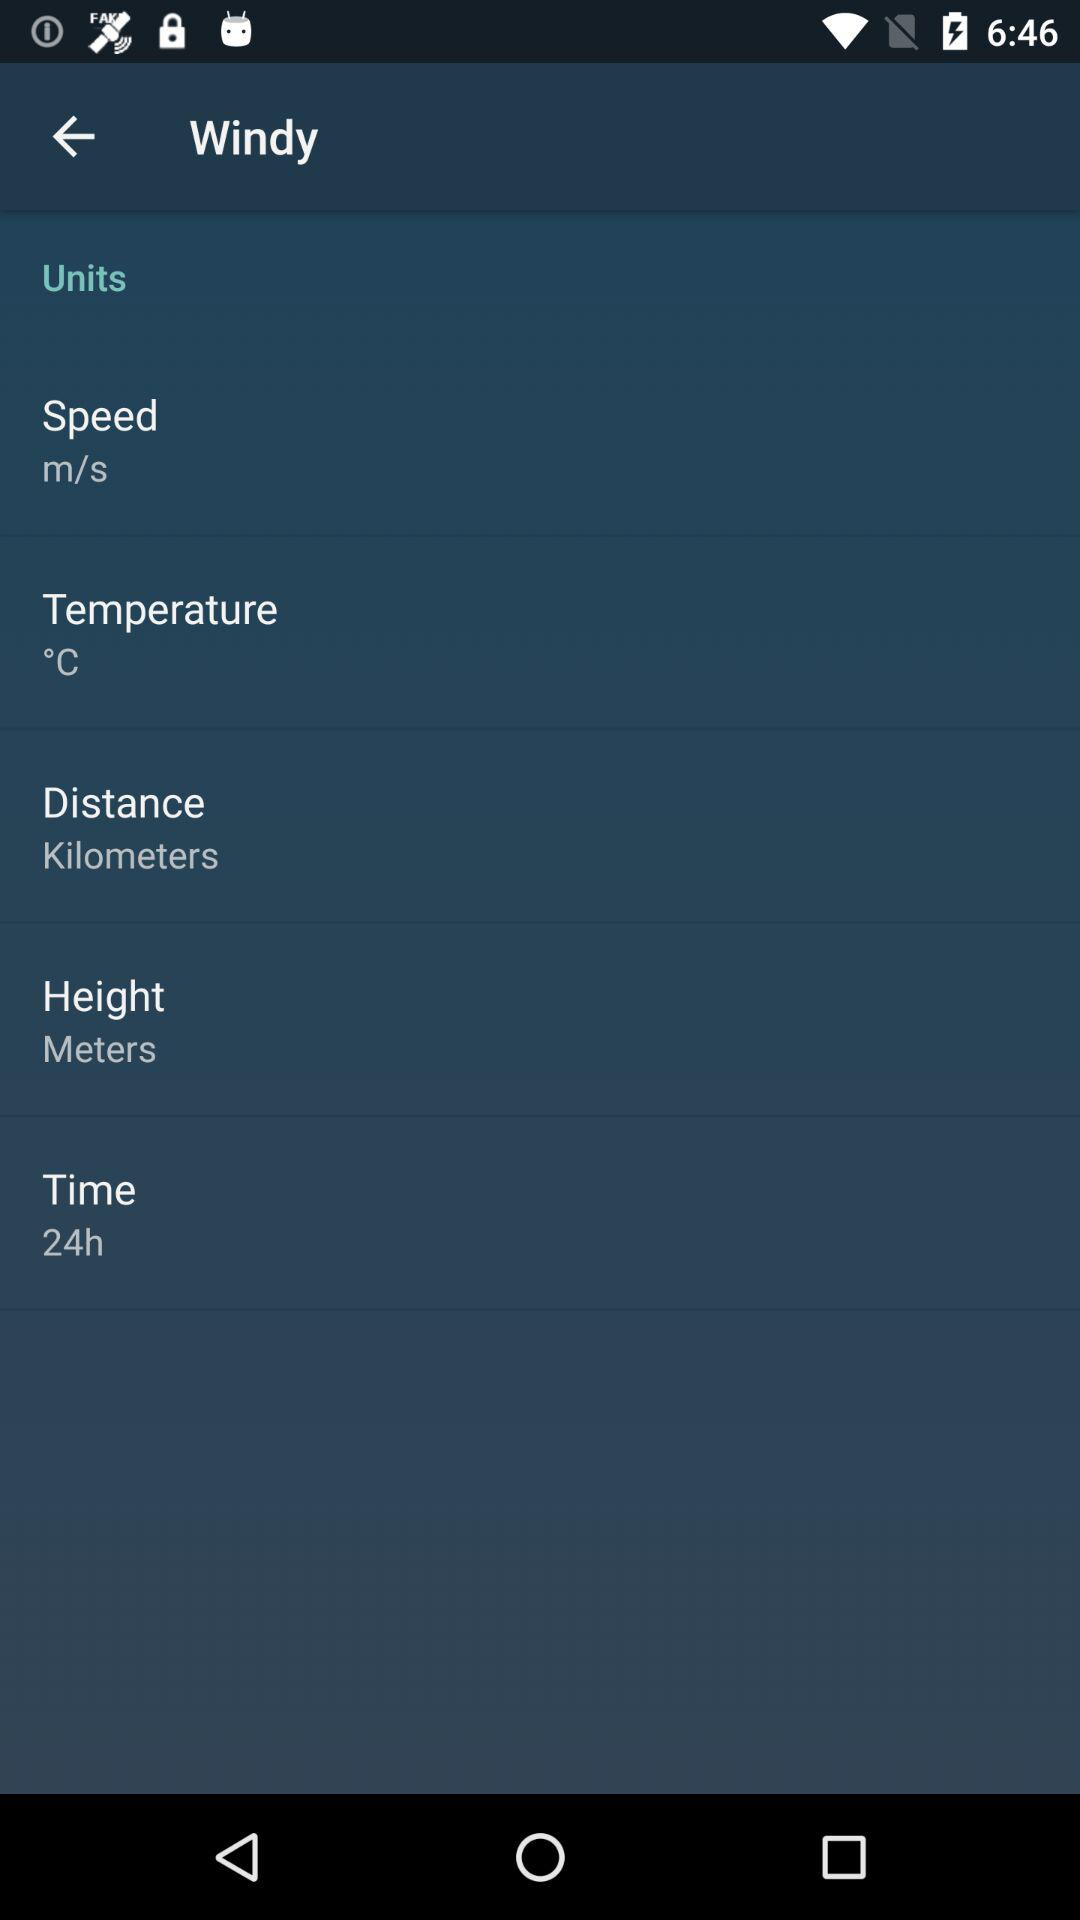What is the given unit of temperature? The given unit of temperature is °C. 